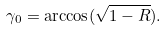<formula> <loc_0><loc_0><loc_500><loc_500>\gamma _ { 0 } = \arccos ( \sqrt { 1 - R } ) .</formula> 